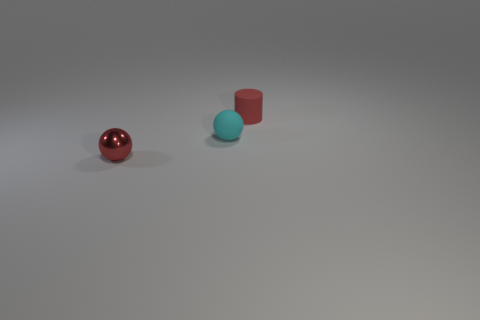How many other small rubber things have the same shape as the small red matte object?
Your answer should be compact. 0. Is there a big object that has the same material as the cyan ball?
Make the answer very short. No. The thing on the left side of the small sphere to the right of the red metallic object is made of what material?
Your answer should be compact. Metal. How big is the matte thing that is in front of the red cylinder?
Your answer should be very brief. Small. Is the color of the small rubber cylinder the same as the small matte sphere that is on the left side of the red matte thing?
Provide a succinct answer. No. Are there any things of the same color as the tiny cylinder?
Your response must be concise. Yes. Are the cyan ball and the red thing behind the red shiny ball made of the same material?
Ensure brevity in your answer.  Yes. What number of large objects are either green rubber spheres or red things?
Your answer should be very brief. 0. There is a small thing that is the same color as the shiny ball; what is it made of?
Make the answer very short. Rubber. Is the number of red metal objects less than the number of small spheres?
Ensure brevity in your answer.  Yes. 